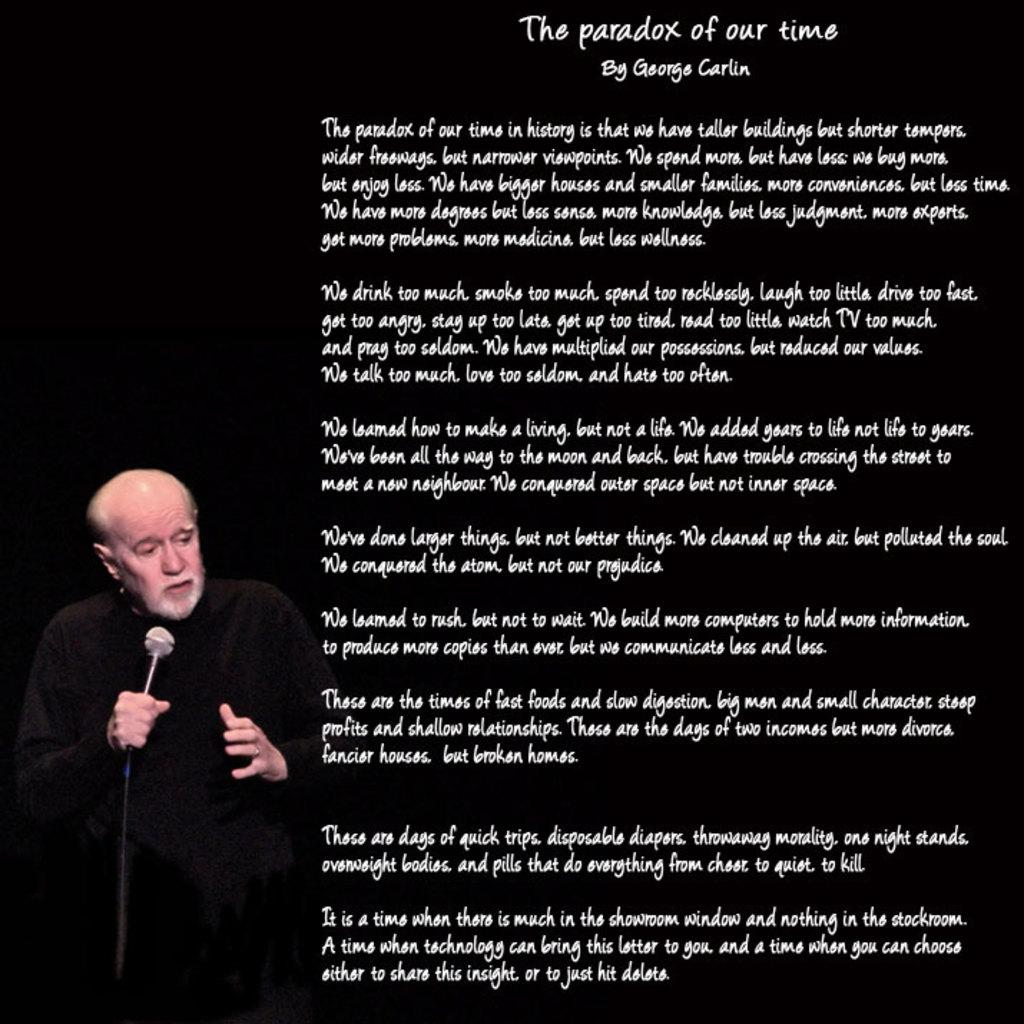What can be seen on the poster in the image? The poster contains text. What is the man in the image doing? The man is holding a mic in his hand. What color is the man wearing in the image? The man is wearing black. Can you describe the man's activity in the image? The man is holding a mic, which suggests he might be speaking or performing. Can you see any goldfish swimming in the image? There are no goldfish present in the image. Is there a church visible in the background of the image? There is no church visible in the image. 